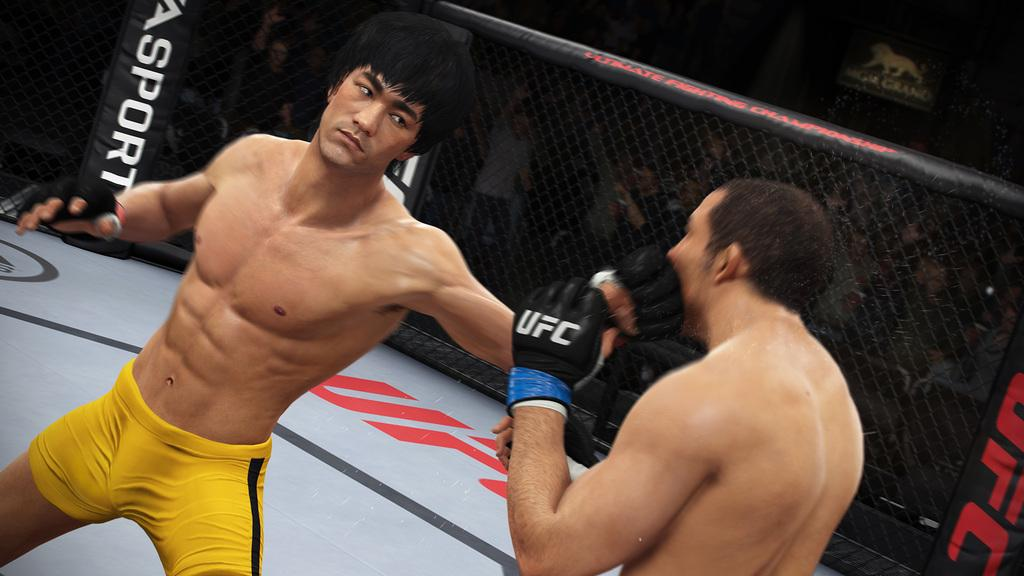<image>
Share a concise interpretation of the image provided. Two UFC  fighters are fighting in a octagon sponsor by" Asport." 